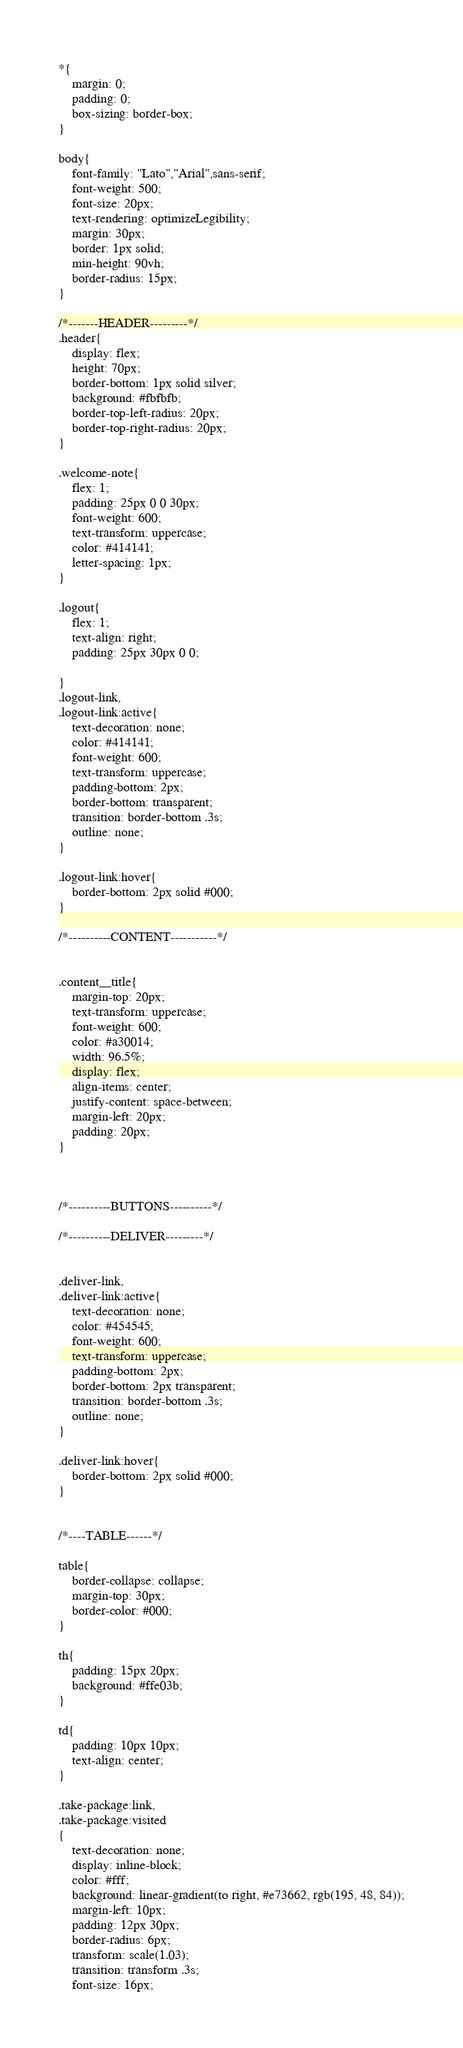<code> <loc_0><loc_0><loc_500><loc_500><_CSS_>*{
    margin: 0;
    padding: 0;
    box-sizing: border-box;
}

body{
    font-family: "Lato","Arial",sans-serif;
    font-weight: 500;
    font-size: 20px;
    text-rendering: optimizeLegibility;    
    margin: 30px;
    border: 1px solid;
    min-height: 90vh;
    border-radius: 15px;
}

/*-------HEADER---------*/
.header{
    display: flex;
    height: 70px;
    border-bottom: 1px solid silver;
    background: #fbfbfb;
    border-top-left-radius: 20px;
    border-top-right-radius: 20px;
}

.welcome-note{
    flex: 1;
    padding: 25px 0 0 30px;
    font-weight: 600;
    text-transform: uppercase;
    color: #414141;
    letter-spacing: 1px;
}

.logout{
    flex: 1;
    text-align: right;
    padding: 25px 30px 0 0;
    
}
.logout-link,
.logout-link:active{
    text-decoration: none;
    color: #414141;
    font-weight: 600;
    text-transform: uppercase;
    padding-bottom: 2px;
    border-bottom: transparent;
    transition: border-bottom .3s;
    outline: none;
}

.logout-link:hover{
    border-bottom: 2px solid #000;
}

/*----------CONTENT-----------*/


.content__title{
    margin-top: 20px;
    text-transform: uppercase;
    font-weight: 600;
    color: #a30014;
    width: 96.5%;
    display: flex;
    align-items: center;
    justify-content: space-between;
    margin-left: 20px;
    padding: 20px;
}



/*----------BUTTONS----------*/

/*----------DELIVER---------*/


.deliver-link,
.deliver-link:active{
    text-decoration: none;
    color: #454545;
    font-weight: 600;
    text-transform: uppercase;
    padding-bottom: 2px;
    border-bottom: 2px transparent;
    transition: border-bottom .3s;
    outline: none;
}

.deliver-link:hover{
    border-bottom: 2px solid #000;
}


/*----TABLE------*/

table{
    border-collapse: collapse;
    margin-top: 30px;
    border-color: #000;
}

th{
    padding: 15px 20px;
    background: #ffe03b;
}

td{
    padding: 10px 10px;
    text-align: center;
}

.take-package:link,
.take-package:visited
{
    text-decoration: none;
    display: inline-block;
    color: #fff;
    background: linear-gradient(to right, #e73662, rgb(195, 48, 84));
    margin-left: 10px;
    padding: 12px 30px;
    border-radius: 6px;
    transform: scale(1.03);
    transition: transform .3s;
    font-size: 16px;</code> 